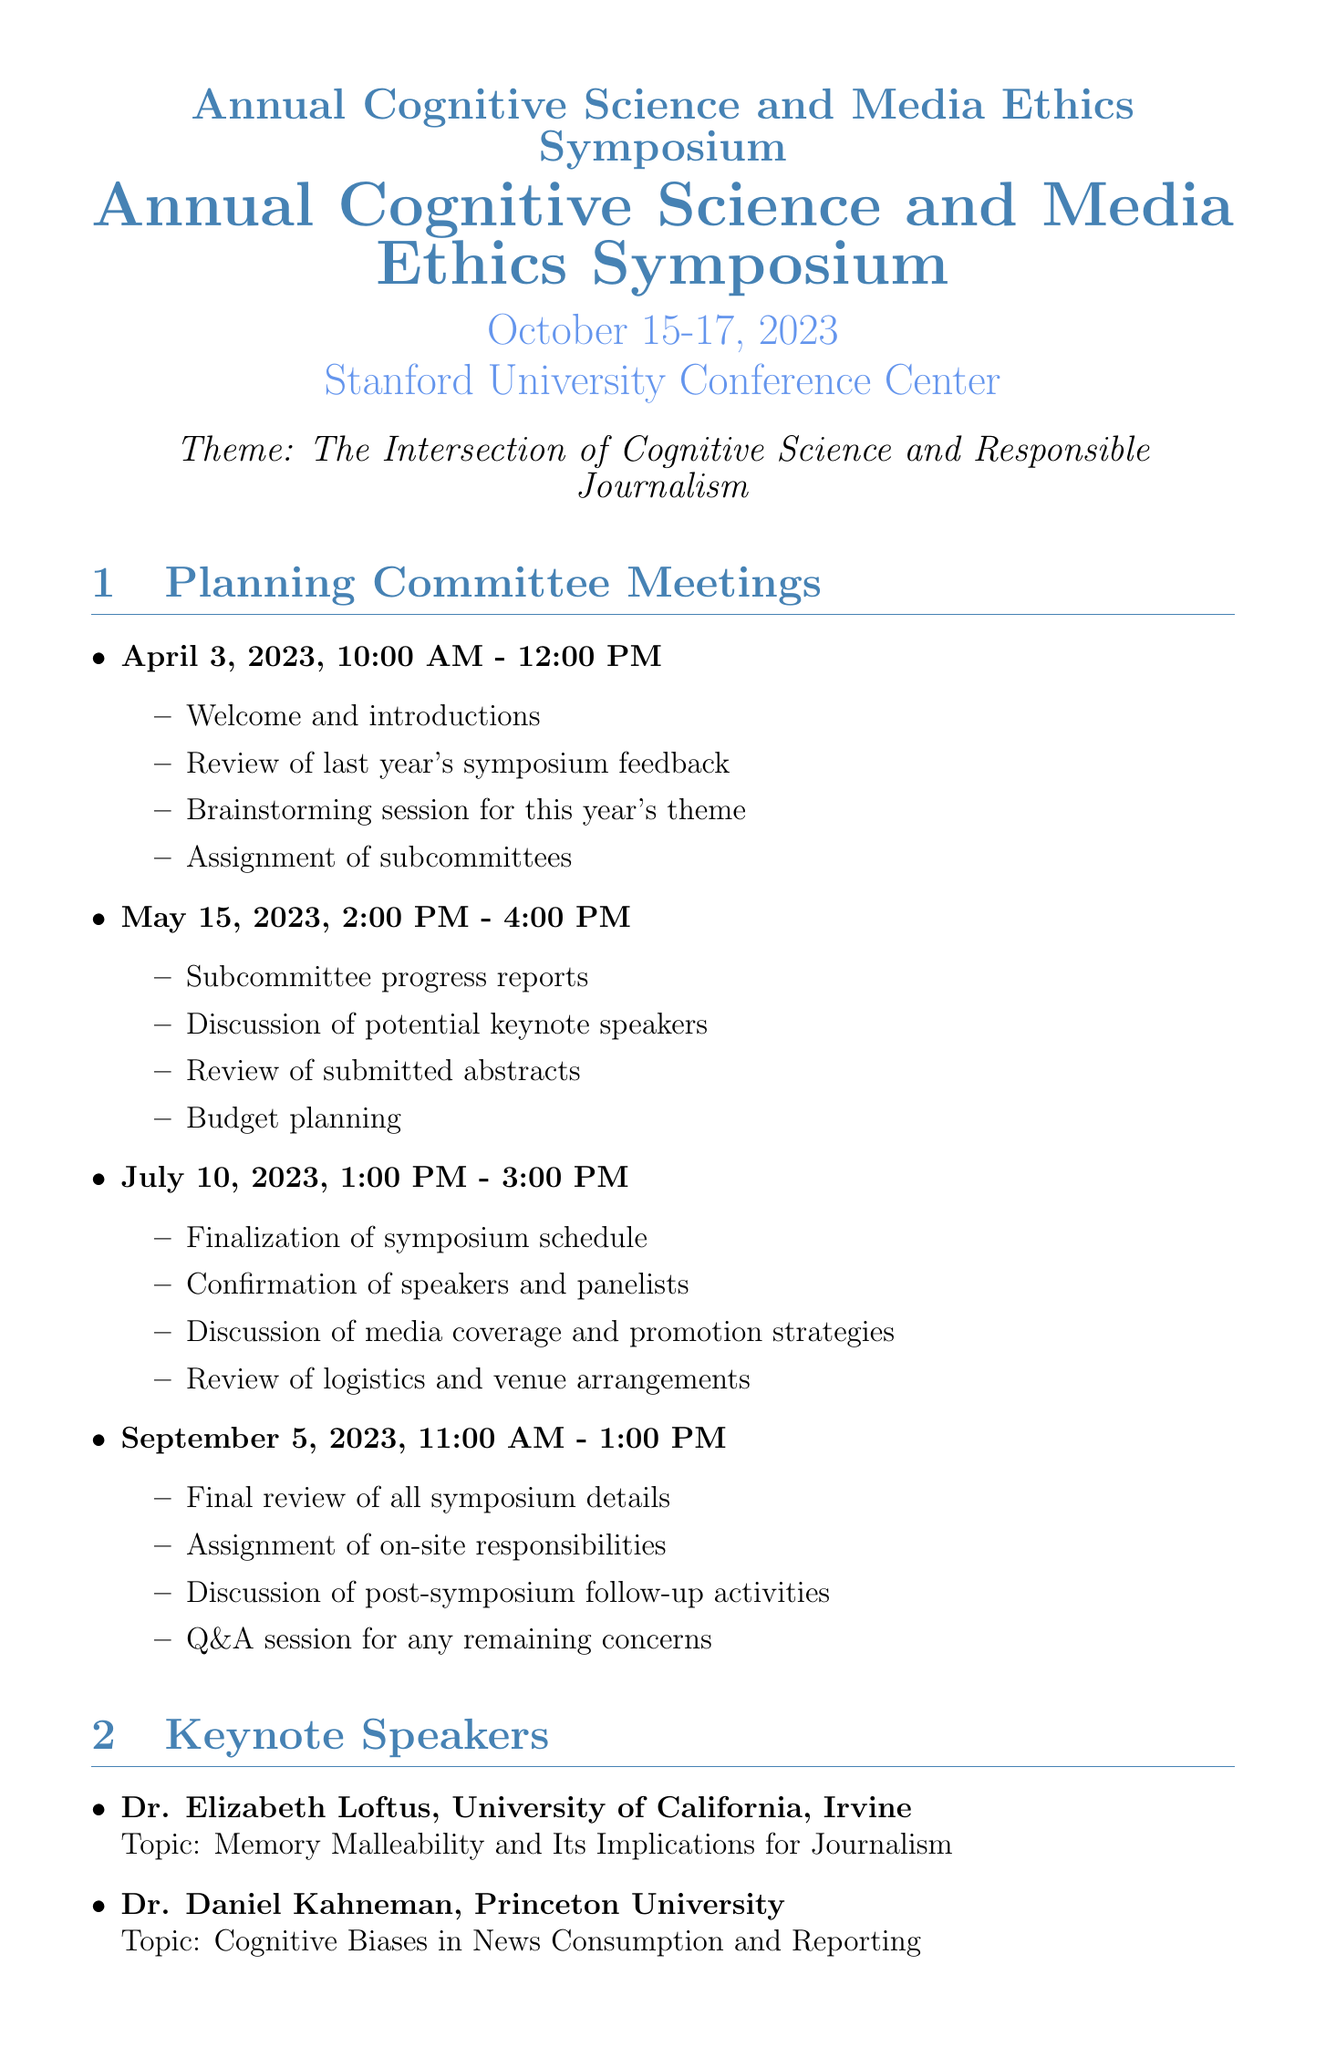What is the date of the symposium? The symposium is scheduled from October 15 to October 17, 2023.
Answer: October 15-17, 2023 Where is the venue for the symposium? The venue for the symposium is specified in the document.
Answer: Stanford University Conference Center What is the theme of the symposium? The theme is explicitly mentioned in the document.
Answer: The Intersection of Cognitive Science and Responsible Journalism Who is the moderator for the panel discussion on media ethics? The document states which panel has a specific moderator listed.
Answer: Dr. Michael Posner How long is the workshop on Cognitive Load Theory in Digital Journalism? The duration of the workshop is provided in the workshop section of the document.
Answer: 90 minutes What are the dates for the planning committee meetings? The dates for committee meetings listed in the document include specific days.
Answer: April 3, May 15, July 10, September 5 How many keynote speakers are listed in the document? The number of keynote speakers can be directly counted from the section.
Answer: 2 What is the title of the fireside chat? The title of the special event is mentioned in the document.
Answer: The Future of Cognitive Science in Journalism Who will facilitate the workshop on Applying Embodied Cognition to Ethical Reporting Practices? The facilitator for this workshop is stated in the workshops section.
Answer: Dr. Lawrence Barsalou 